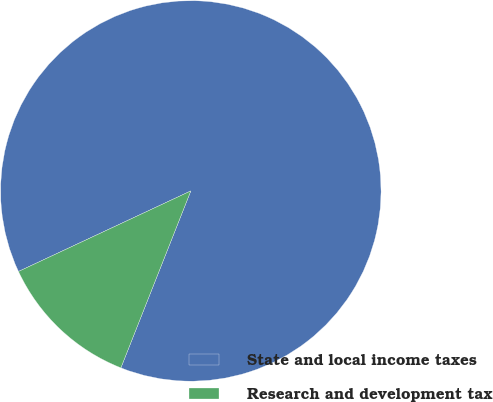<chart> <loc_0><loc_0><loc_500><loc_500><pie_chart><fcel>State and local income taxes<fcel>Research and development tax<nl><fcel>87.95%<fcel>12.05%<nl></chart> 